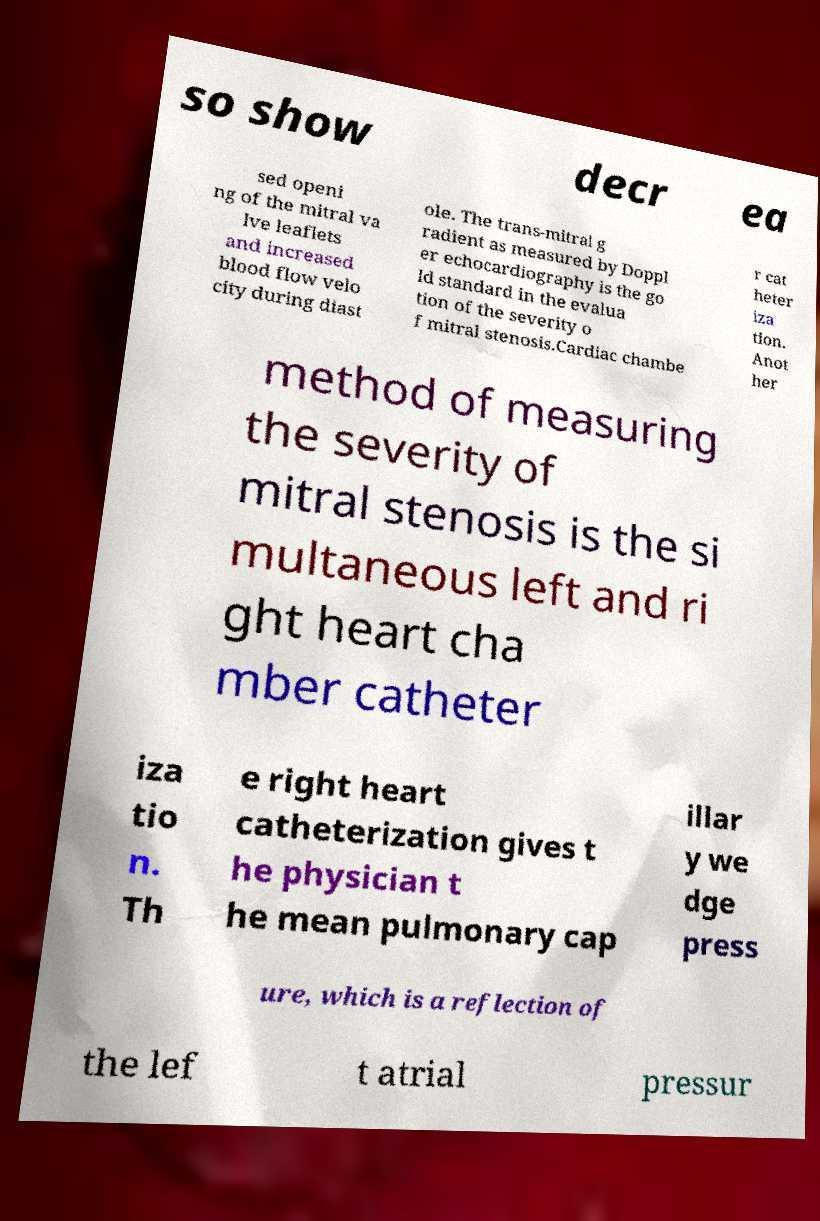I need the written content from this picture converted into text. Can you do that? so show decr ea sed openi ng of the mitral va lve leaflets and increased blood flow velo city during diast ole. The trans-mitral g radient as measured by Doppl er echocardiography is the go ld standard in the evalua tion of the severity o f mitral stenosis.Cardiac chambe r cat heter iza tion. Anot her method of measuring the severity of mitral stenosis is the si multaneous left and ri ght heart cha mber catheter iza tio n. Th e right heart catheterization gives t he physician t he mean pulmonary cap illar y we dge press ure, which is a reflection of the lef t atrial pressur 